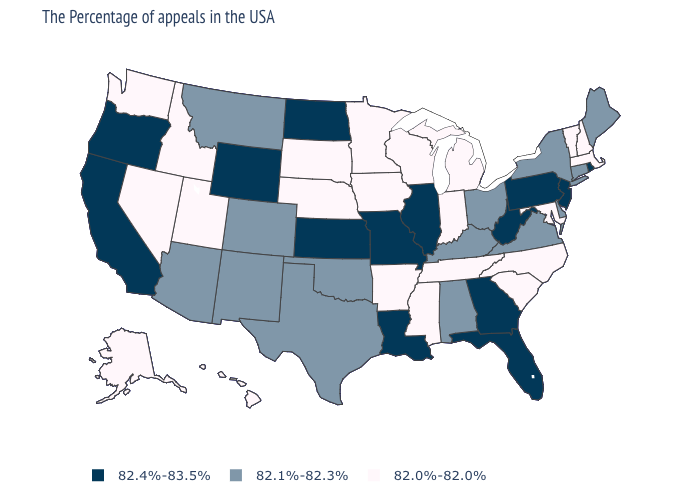What is the lowest value in the South?
Keep it brief. 82.0%-82.0%. What is the value of Wyoming?
Answer briefly. 82.4%-83.5%. Name the states that have a value in the range 82.4%-83.5%?
Give a very brief answer. Rhode Island, New Jersey, Pennsylvania, West Virginia, Florida, Georgia, Illinois, Louisiana, Missouri, Kansas, North Dakota, Wyoming, California, Oregon. What is the value of Florida?
Quick response, please. 82.4%-83.5%. What is the value of Texas?
Be succinct. 82.1%-82.3%. What is the lowest value in the Northeast?
Quick response, please. 82.0%-82.0%. What is the value of New Mexico?
Write a very short answer. 82.1%-82.3%. How many symbols are there in the legend?
Give a very brief answer. 3. Name the states that have a value in the range 82.4%-83.5%?
Keep it brief. Rhode Island, New Jersey, Pennsylvania, West Virginia, Florida, Georgia, Illinois, Louisiana, Missouri, Kansas, North Dakota, Wyoming, California, Oregon. What is the value of Colorado?
Concise answer only. 82.1%-82.3%. Does Florida have the lowest value in the South?
Concise answer only. No. Name the states that have a value in the range 82.1%-82.3%?
Short answer required. Maine, Connecticut, New York, Delaware, Virginia, Ohio, Kentucky, Alabama, Oklahoma, Texas, Colorado, New Mexico, Montana, Arizona. What is the value of Michigan?
Quick response, please. 82.0%-82.0%. What is the value of Alaska?
Quick response, please. 82.0%-82.0%. What is the value of Ohio?
Short answer required. 82.1%-82.3%. 